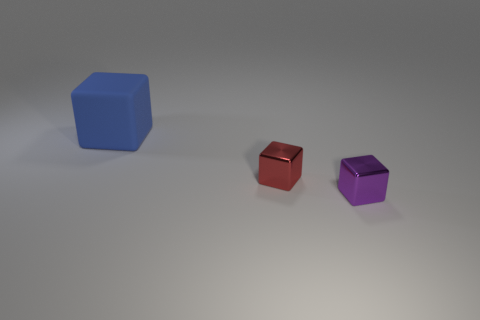There is a thing that is the same material as the small red cube; what color is it?
Ensure brevity in your answer.  Purple. What size is the object behind the red object?
Ensure brevity in your answer.  Large. Are there fewer rubber things to the left of the big cube than small purple matte cylinders?
Offer a very short reply. No. Is there anything else that is the same shape as the purple shiny object?
Keep it short and to the point. Yes. Are there fewer rubber objects than large gray rubber spheres?
Offer a very short reply. No. What color is the metal cube to the left of the shiny object that is in front of the red block?
Your response must be concise. Red. There is a large blue block that is left of the tiny object that is left of the small block to the right of the red object; what is it made of?
Provide a succinct answer. Rubber. There is a object that is on the left side of the red metal cube; is its size the same as the red object?
Keep it short and to the point. No. What is the material of the thing left of the small red metallic block?
Provide a short and direct response. Rubber. Is the number of small red objects greater than the number of yellow rubber objects?
Keep it short and to the point. Yes. 